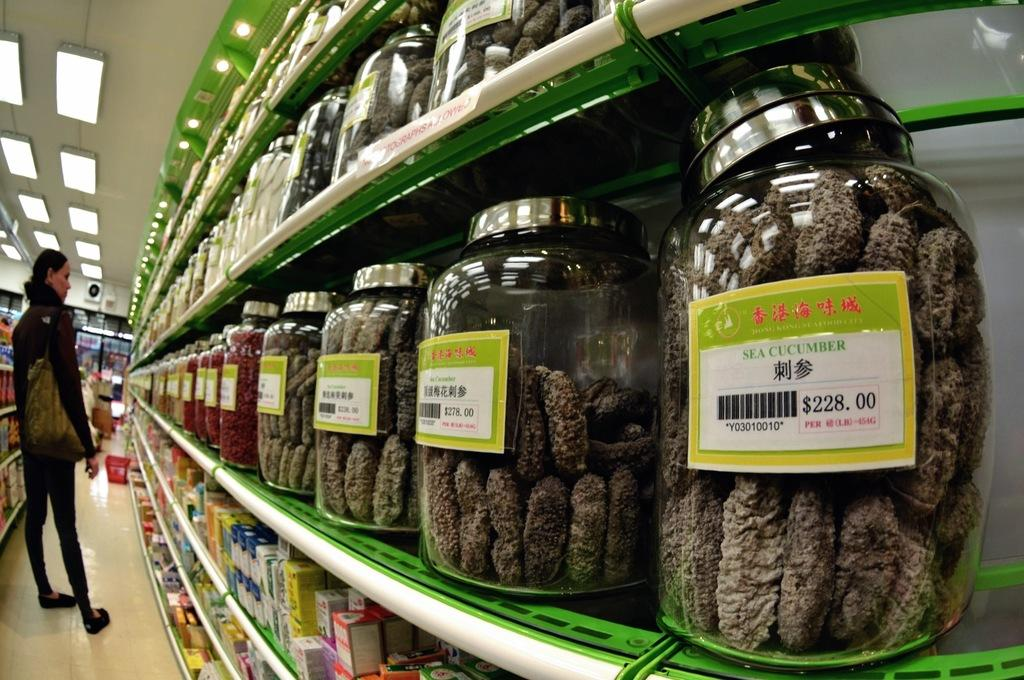Provide a one-sentence caption for the provided image. A store with sea cucumber jars lined up. 